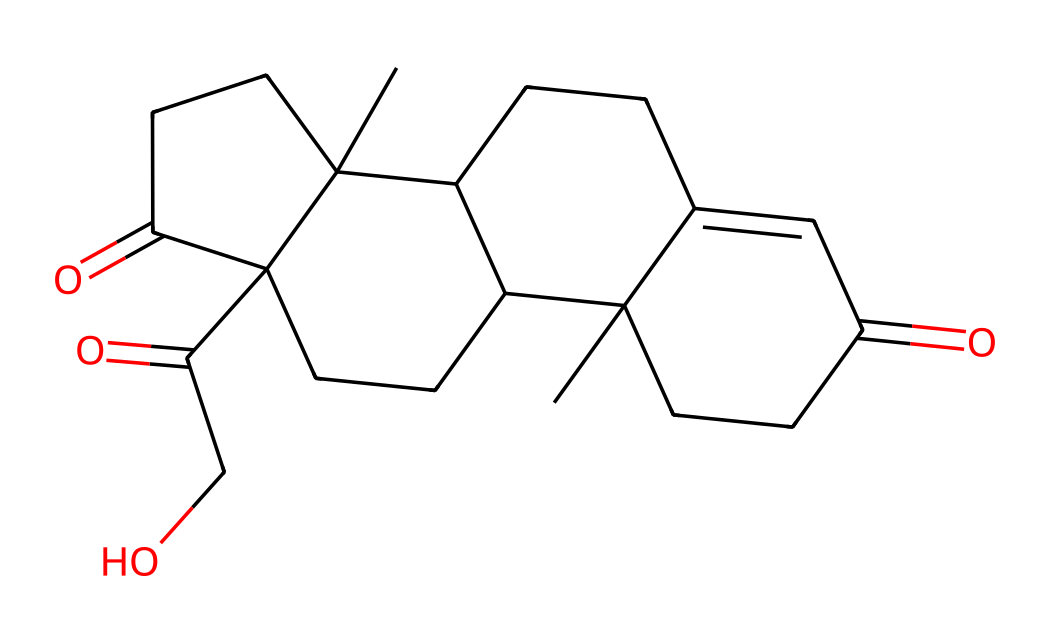How many carbon atoms are in cortisol? By examining the SMILES notation, we count the occurrences of 'C', which represent carbon atoms. In the molecular structure provided, there are 21 carbon atoms.
Answer: 21 What functional groups are present in cortisol? By analyzing the structure derived from the SMILES, we find carbonyl groups (=O) and hydroxyl groups (-OH) indicative of ketones and alcohols in the molecule.
Answer: ketone and alcohol What type of chemical is cortisol classified as? Cortisol is classified as a steroid hormone, which is identified by its multi-ring structure common in steroid compounds derived from cholesterol.
Answer: steroid hormone How many oxygen atoms are present in cortisol? The SMILES notation includes the symbol 'O' for oxygen atoms. Counting these indicates there are 5 oxygen atoms present in the structure of cortisol.
Answer: 5 What type of bonds are primarily found in cortisol’s structure? The structure is comprised mainly of single and double bonds between carbon atoms, and the presence of carbon-oxygen bonds suggests it contains both types of bonding throughout its molecular structure.
Answer: single and double bonds What is the significance of cortisol in the body? Cortisol is known as the stress hormone and plays a critical role in the body, particularly in metabolism regulation and response to stress, indicating its functional significance beyond its chemical structure.
Answer: stress hormone 